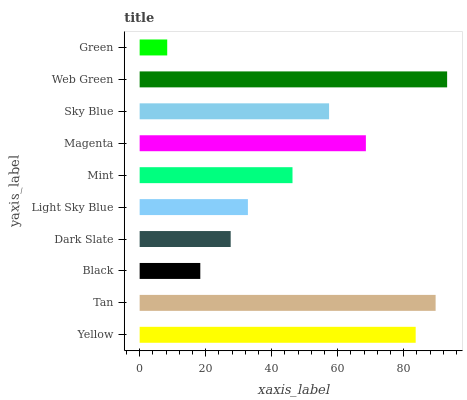Is Green the minimum?
Answer yes or no. Yes. Is Web Green the maximum?
Answer yes or no. Yes. Is Tan the minimum?
Answer yes or no. No. Is Tan the maximum?
Answer yes or no. No. Is Tan greater than Yellow?
Answer yes or no. Yes. Is Yellow less than Tan?
Answer yes or no. Yes. Is Yellow greater than Tan?
Answer yes or no. No. Is Tan less than Yellow?
Answer yes or no. No. Is Sky Blue the high median?
Answer yes or no. Yes. Is Mint the low median?
Answer yes or no. Yes. Is Magenta the high median?
Answer yes or no. No. Is Green the low median?
Answer yes or no. No. 